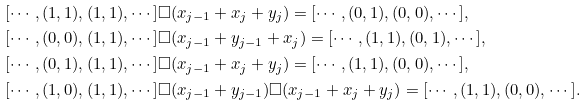<formula> <loc_0><loc_0><loc_500><loc_500>& [ \cdots , ( 1 , 1 ) , ( 1 , 1 ) , \cdots ] \square ( x _ { j - 1 } + x _ { j } + y _ { j } ) = [ \cdots , ( 0 , 1 ) , ( 0 , 0 ) , \cdots ] , \\ & [ \cdots , ( 0 , 0 ) , ( 1 , 1 ) , \cdots ] \square ( x _ { j - 1 } + y _ { j - 1 } + x _ { j } ) = [ \cdots , ( 1 , 1 ) , ( 0 , 1 ) , \cdots ] , \\ & [ \cdots , ( 0 , 1 ) , ( 1 , 1 ) , \cdots ] \square ( x _ { j - 1 } + x _ { j } + y _ { j } ) = [ \cdots , ( 1 , 1 ) , ( 0 , 0 ) , \cdots ] , \\ & [ \cdots , ( 1 , 0 ) , ( 1 , 1 ) , \cdots ] \square ( x _ { j - 1 } + y _ { j - 1 } ) \square ( x _ { j - 1 } + x _ { j } + y _ { j } ) = [ \cdots , ( 1 , 1 ) , ( 0 , 0 ) , \cdots ] .</formula> 